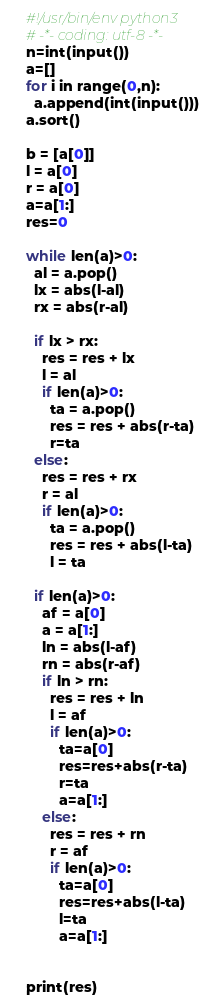Convert code to text. <code><loc_0><loc_0><loc_500><loc_500><_Python_>#!/usr/bin/env python3
# -*- coding: utf-8 -*-
n=int(input())
a=[]
for i in range(0,n):
  a.append(int(input()))
a.sort()

b = [a[0]]
l = a[0]
r = a[0]
a=a[1:]
res=0

while len(a)>0:
  al = a.pop()
  lx = abs(l-al)
  rx = abs(r-al)

  if lx > rx:
    res = res + lx
    l = al
    if len(a)>0:
      ta = a.pop()
      res = res + abs(r-ta)
      r=ta
  else:
    res = res + rx
    r = al
    if len(a)>0:
      ta = a.pop()
      res = res + abs(l-ta)
      l = ta

  if len(a)>0:
    af = a[0]
    a = a[1:]
    ln = abs(l-af)
    rn = abs(r-af)
    if ln > rn:
      res = res + ln
      l = af
      if len(a)>0:
        ta=a[0]
        res=res+abs(r-ta)
        r=ta
        a=a[1:]
    else:
      res = res + rn
      r = af
      if len(a)>0:
        ta=a[0]
        res=res+abs(l-ta)
        l=ta
        a=a[1:]


print(res)
</code> 